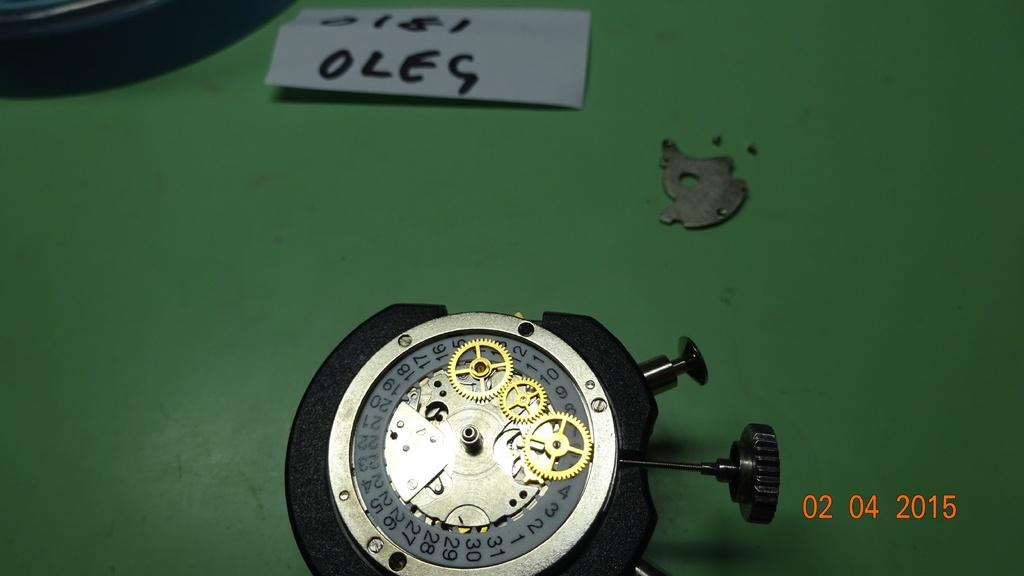What is the color of the object in the image? The object in the image is black. What type of material is the object made of? The provided facts do not specify the material of the object. What is the other item visible in the image? There is a paper in the image. What is the color of the surface on which the objects are placed? The objects are on a green color surface. What type of cloth is draped over the stone in the image? There is no stone or cloth present in the image. 